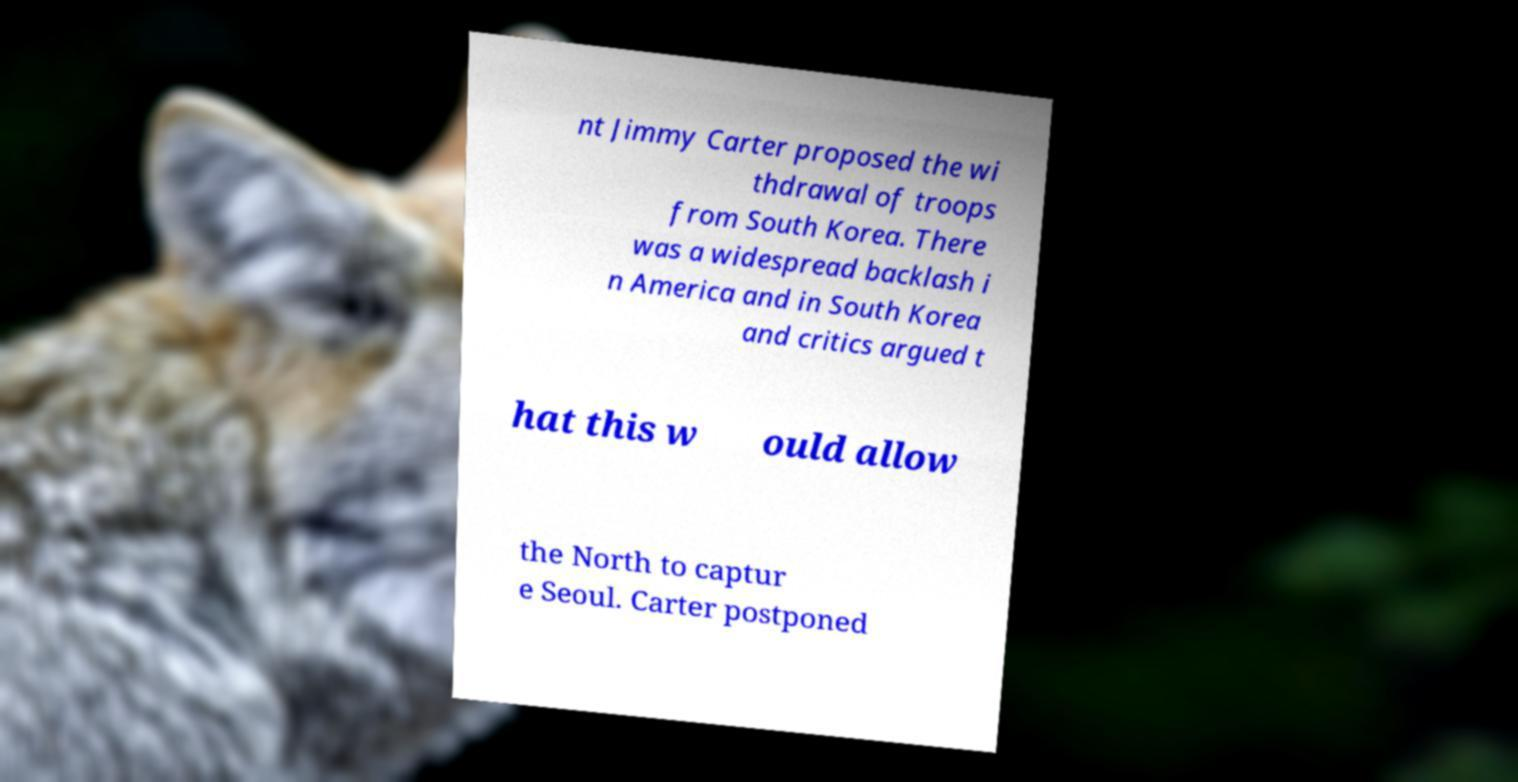Please read and relay the text visible in this image. What does it say? nt Jimmy Carter proposed the wi thdrawal of troops from South Korea. There was a widespread backlash i n America and in South Korea and critics argued t hat this w ould allow the North to captur e Seoul. Carter postponed 